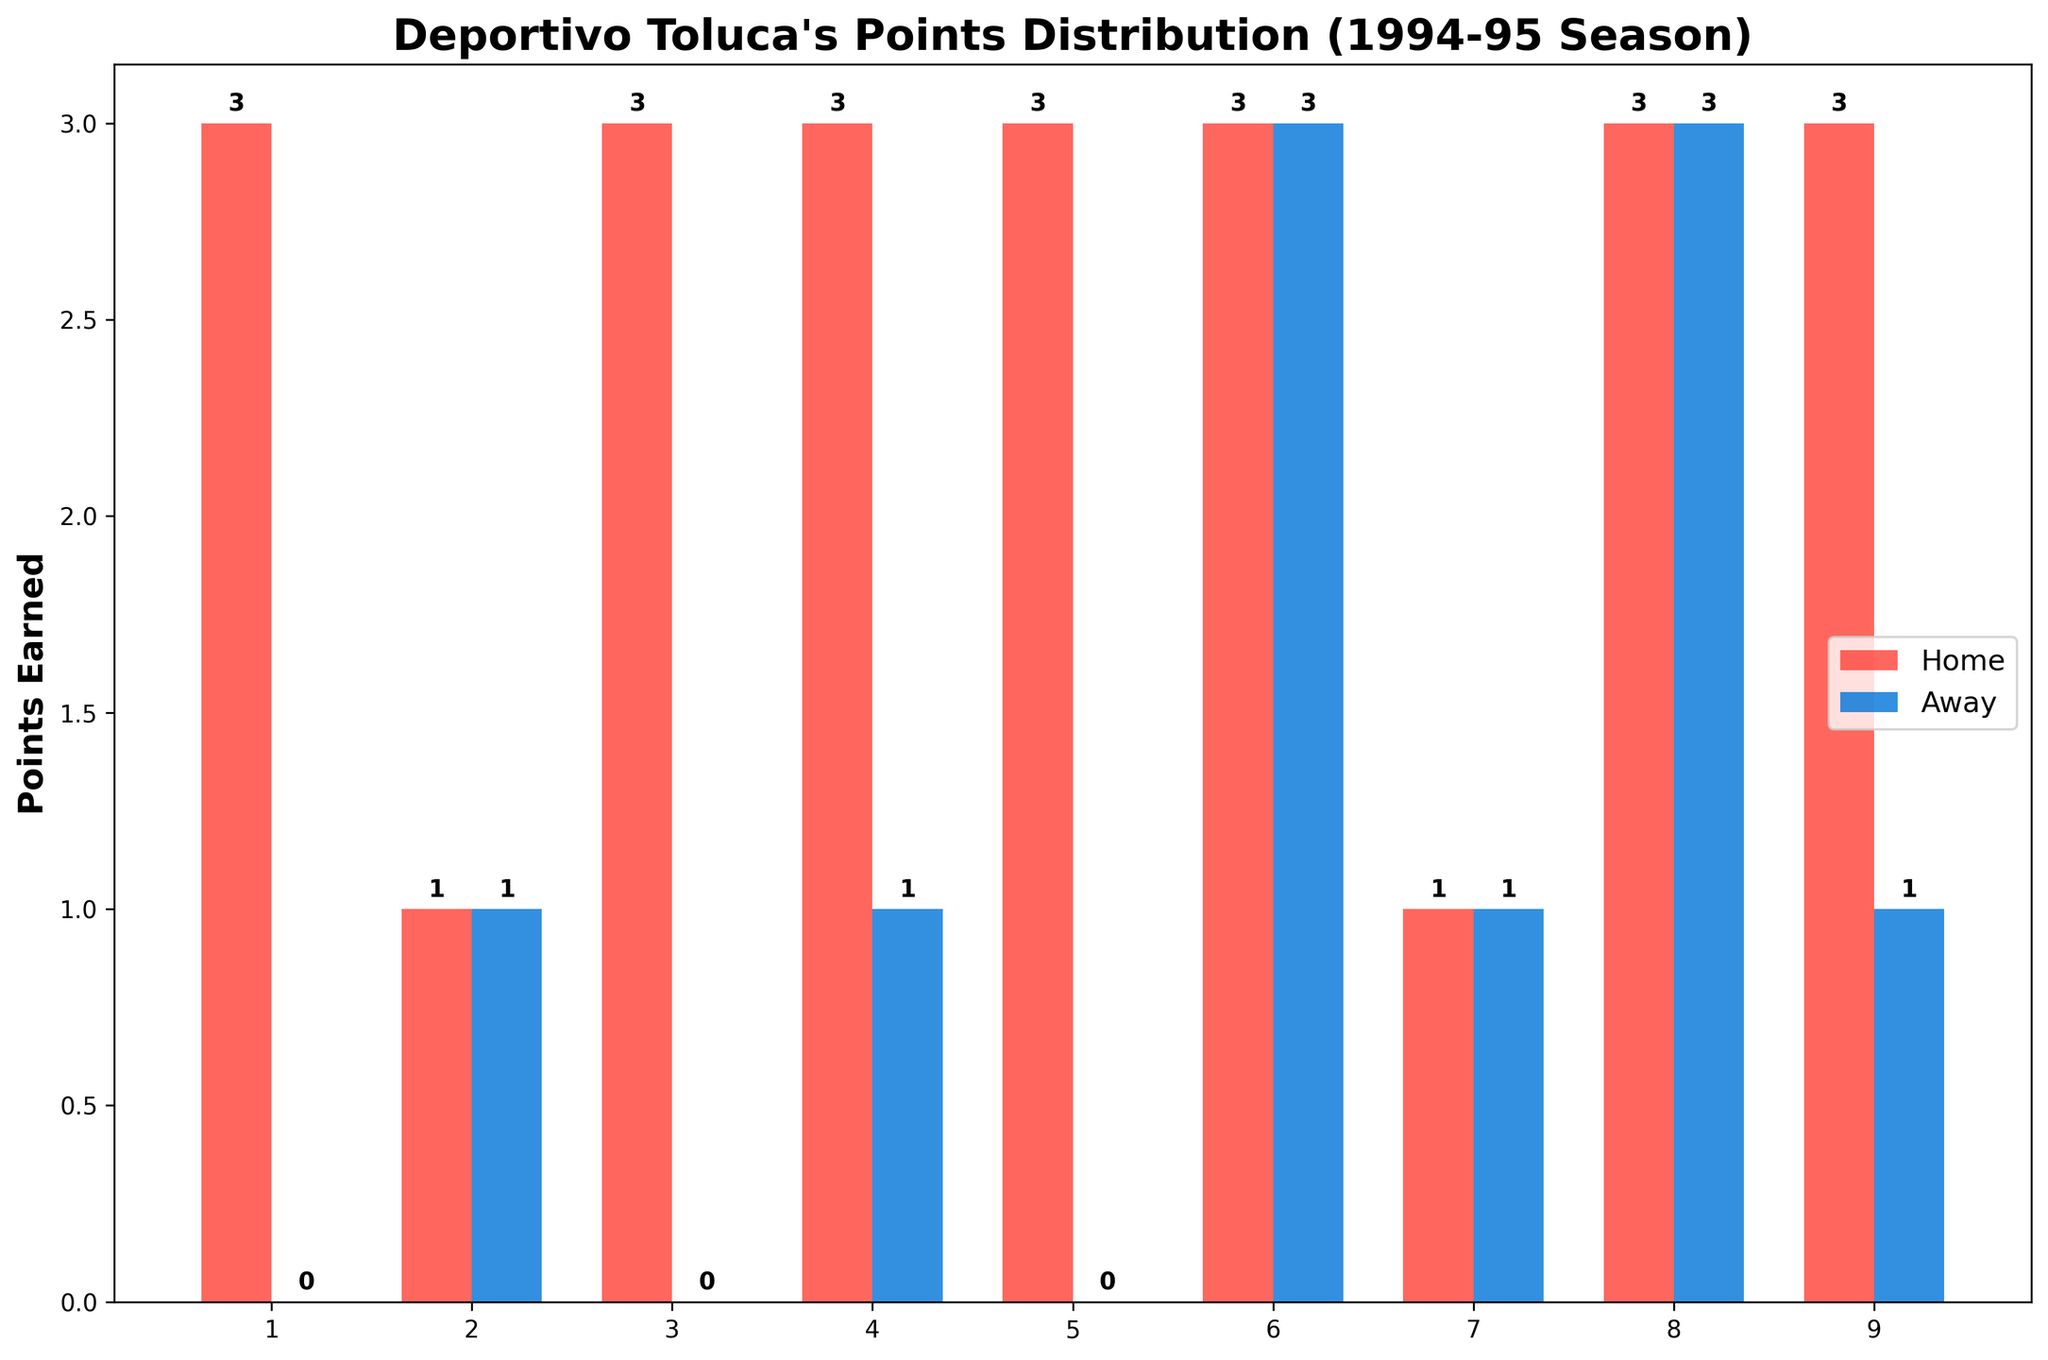What's the total number of points Deportivo Toluca earned at home? Count all the bar heights for home matches. The points are 3, 1, 3, 3, 3, 3, 1, 3, 3. Adding them up: 3+1+3+3+3+3+1+3+3 = 23
Answer: 23 What's the total number of points Deportivo Toluca earned away? Count all the bar heights for away matches. The points are 0, 1, 0, 1, 0, 3, 1, 3, 1. Adding them up: 0+1+0+1+0+3+1+3+1 = 10
Answer: 10 Which match type did Deportivo Toluca earn more points in, home or away? Compare the total points earned at home (23) and away (10). Since 23 > 10, they earned more points in home matches.
Answer: Home What is the average number of points earned in away matches? Calculate the average of all away match points: (0+1+0+1+0+3+1+3+1)/9. The sum is 10, and it divides by 9 to get approximately 1.11
Answer: 1.11 Which match had the highest points earned in away matches? Identify the tallest bar in the away matches section. It corresponds to Monterrey and Correcaminos UAT, both with 3 points.
Answer: Monterrey, Correcaminos UAT What is the difference in points earned between the home match against Atlante and the away match against UNAM? The points for the home match against Atlante are 3 and for away against UNAM are 0. The difference is 3-0 = 3
Answer: 3 How many away matches resulted in 0 points? Count the number of bars in away matches that have a height of 0. There are three such matches (UNAM, Necaxa, and Cruz Azul).
Answer: 3 Which match type had more variation in points earned, home or away? Look at the distribution and range of bar heights for both match types. Home matches range from 1 to 3 points, while away matches range from 0 to 3 points, indicating more variation in away matches.
Answer: Away 